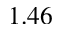Convert formula to latex. <formula><loc_0><loc_0><loc_500><loc_500>1 . 4 6</formula> 